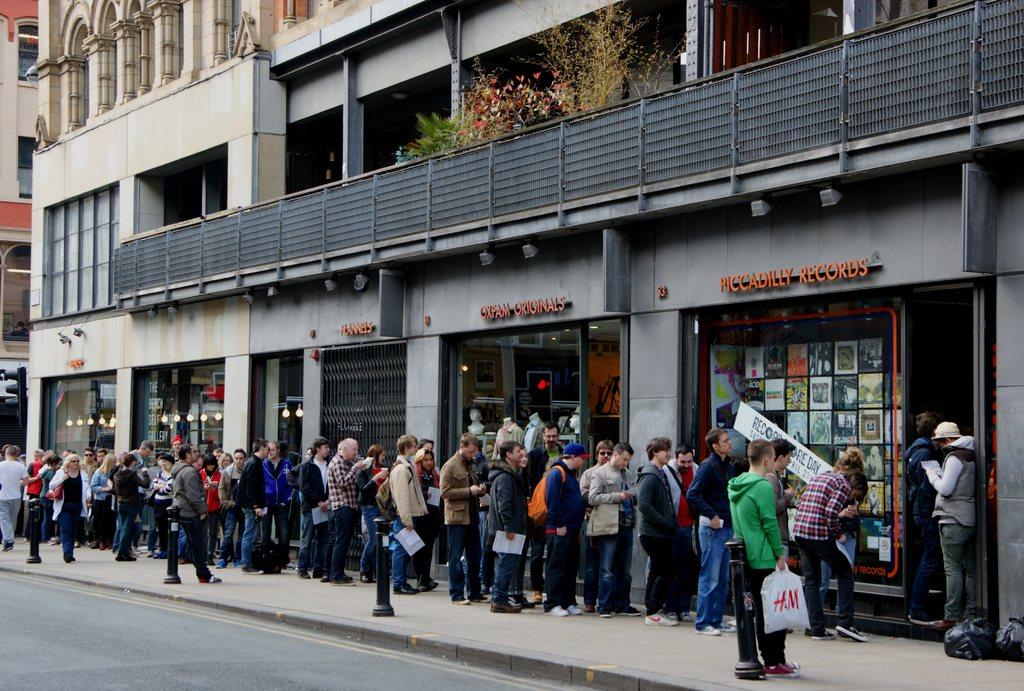What brand of clothing is in the white bag?
Ensure brevity in your answer.  H&m. 